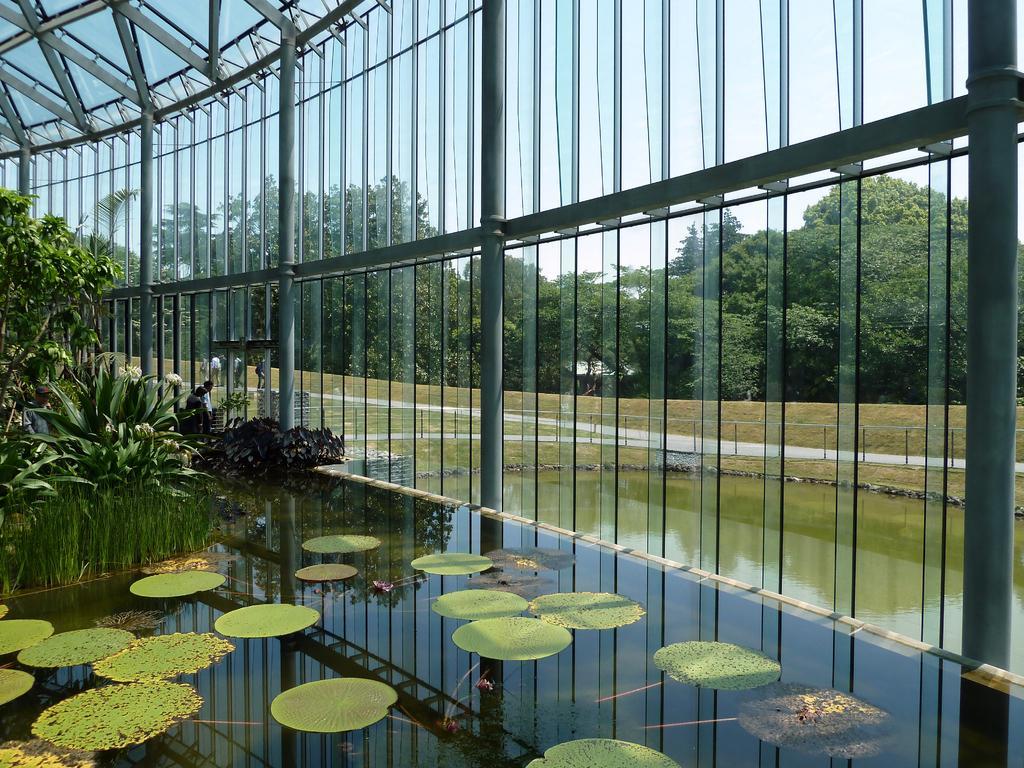In one or two sentences, can you explain what this image depicts? In the image we can see there are people wearing clothes. These are the plants, lotus leaves, water, trees and a sky. These are the poles and these are the glass sheets. 